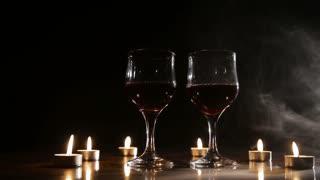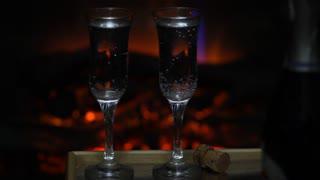The first image is the image on the left, the second image is the image on the right. For the images shown, is this caption "An image shows wisps of white smoke around two glasses of dark red wine, standing near candles." true? Answer yes or no. Yes. 